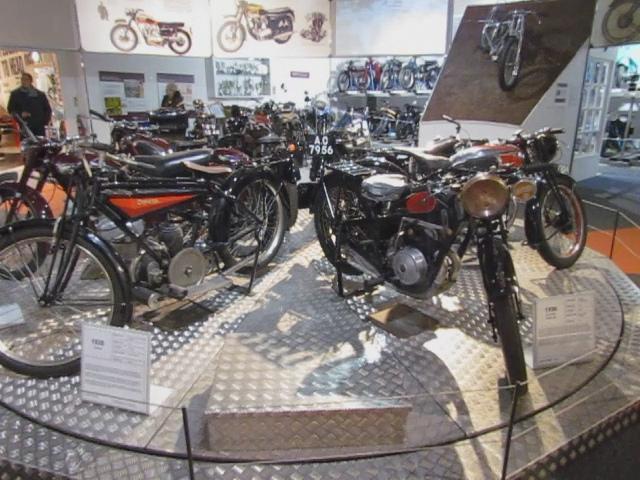What type room is this?
From the following four choices, select the correct answer to address the question.
Options: Parking garage, bathroom, living, showroom. Showroom. What sort of shop is this?
Answer the question by selecting the correct answer among the 4 following choices.
Options: Motorcycle sales, car sales, used car, motorcycle repair. Motorcycle sales. 